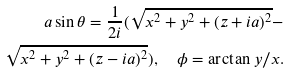<formula> <loc_0><loc_0><loc_500><loc_500>a \sin { \theta } = \frac { 1 } { 2 i } ( \sqrt { x ^ { 2 } + y ^ { 2 } + ( z + i a ) ^ { 2 } } - \\ \sqrt { x ^ { 2 } + y ^ { 2 } + ( z - i a ) ^ { 2 } } ) , \quad \phi = \arctan { y / x } .</formula> 